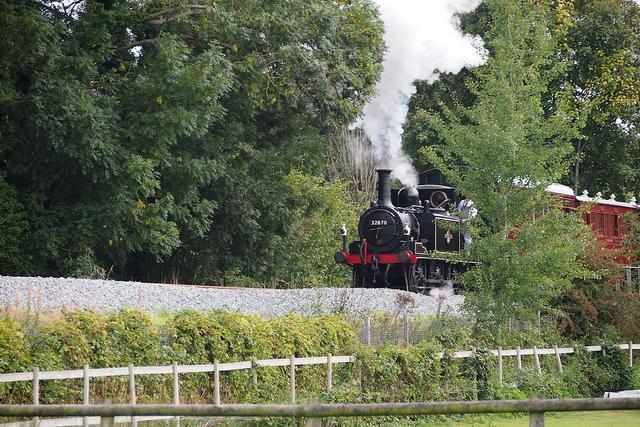How many trains?
Give a very brief answer. 1. How many trains are there?
Give a very brief answer. 1. How many pairs of scissors are in the picture?
Give a very brief answer. 0. 